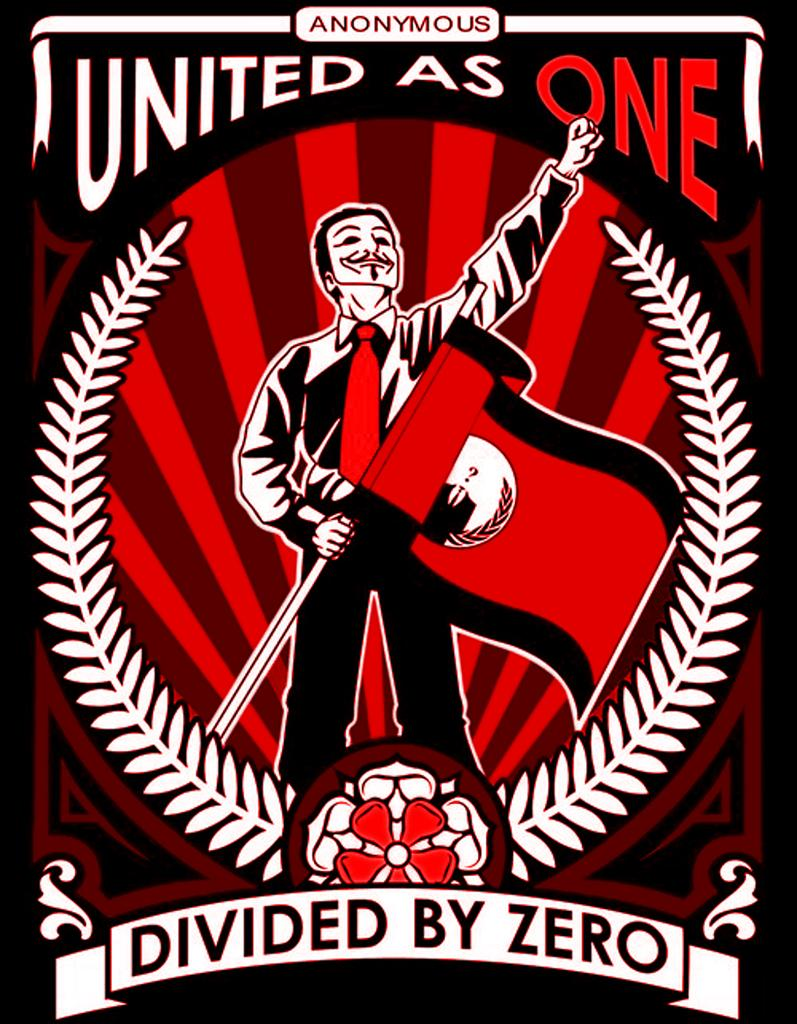What type of image is being described? The image is a poster. What elements are present on the poster? There are flowers, leaves, a man holding a flag, and text on the poster. How is the man holding the flag? The man is holding the flag with his hand. What type of cable can be seen connecting the flowers to the man holding the flag? There is no cable present in the image; it is a poster featuring flowers, leaves, a man holding a flag, and text. --- Facts: 1. There is a person sitting on a chair in the image. 2. The person is holding a book. 3. The book has a blue cover. 4. There is a table next to the chair. 5. There is a lamp on the table. Absurd Topics: ocean, parrot, bicycle Conversation: What is the person in the image doing? The person is sitting on a chair in the image. What object is the person holding? The person is holding a book. What color is the book's cover? The book has a blue cover. What is located next to the chair? There is a table next to the chair. What is on the table? There is a lamp on the table. Reasoning: Let's think step by step in order to produce the conversation. We start by identifying the main subject in the image, which is the person sitting on a chair. Then, we expand the conversation to include other items that are also visible, such as the book, the book's blue cover, the table, and the lamp. Each question is designed to elicit a specific detail about the image that is known from the provided facts. Absurd Question/Answer: Can you see the ocean in the background of the image? There is no ocean present in the image; it features a person sitting on a chair, holding a book with a blue cover, a table, and a lamp. 